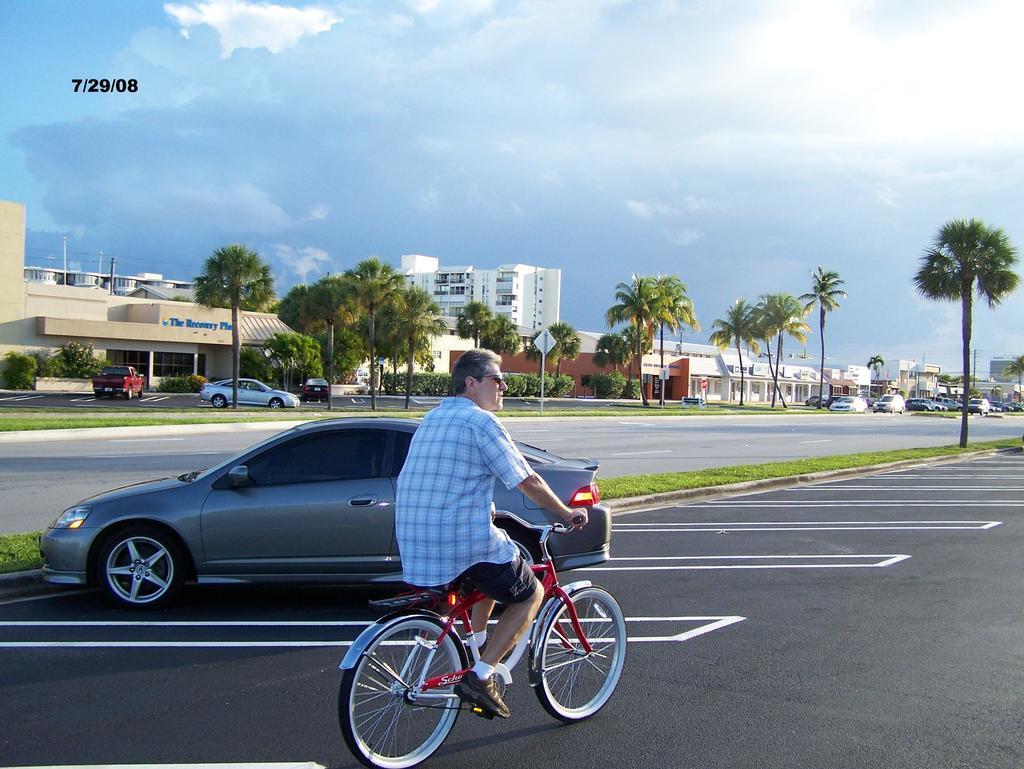Can you describe this image briefly? Here we can see a man riding a bicycle on the road. There is a car parked on the left side. In the background we can see a house, a building, a tree and a sky with clouds. 